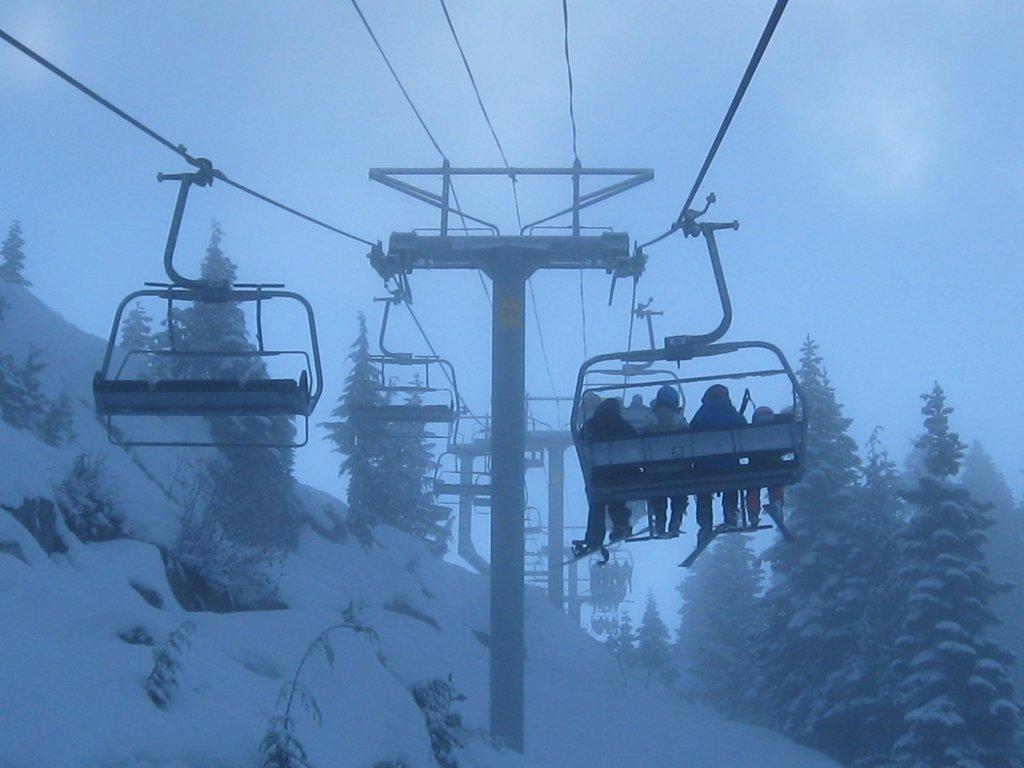Please provide a concise description of this image. In this picture we can see some people sitting on chair lifts, trees, poles, snow and in the background we can see the sky. 